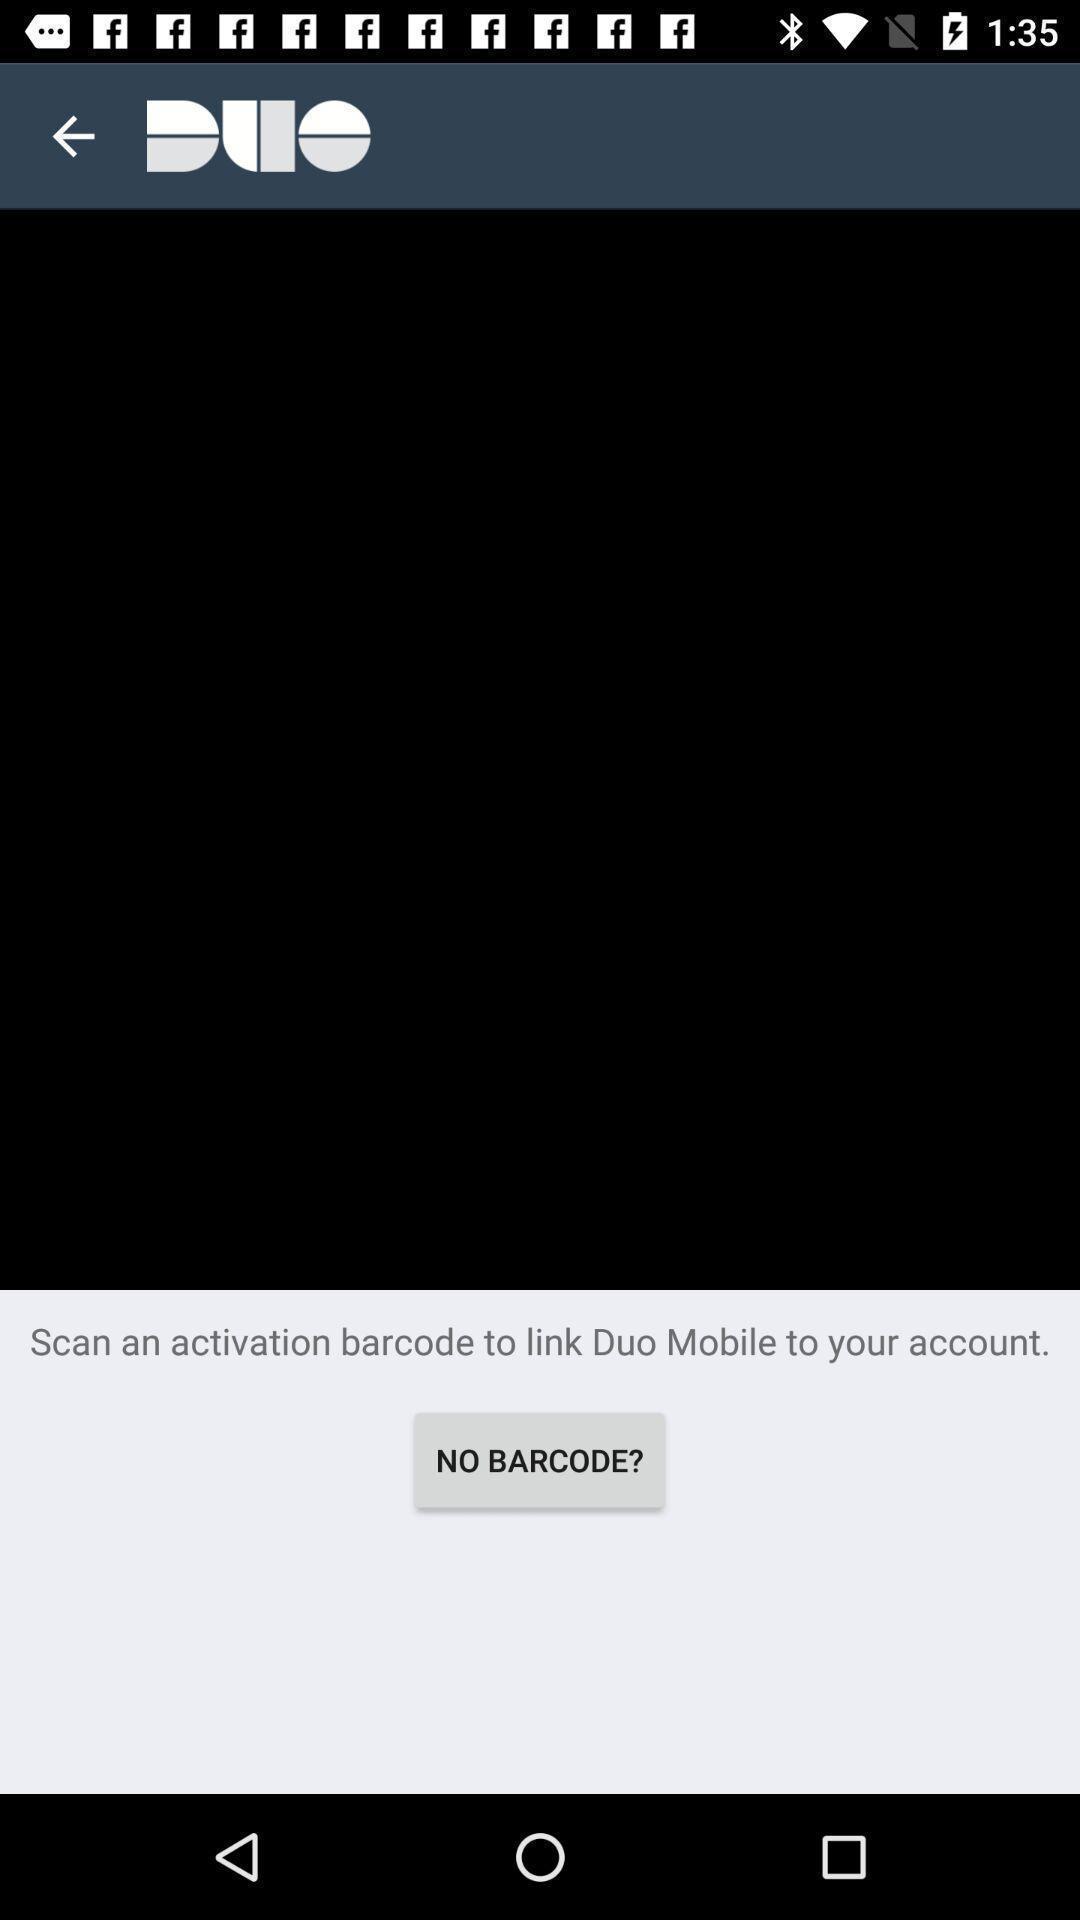Tell me what you see in this picture. Pop up displaying to scan a bar code. 